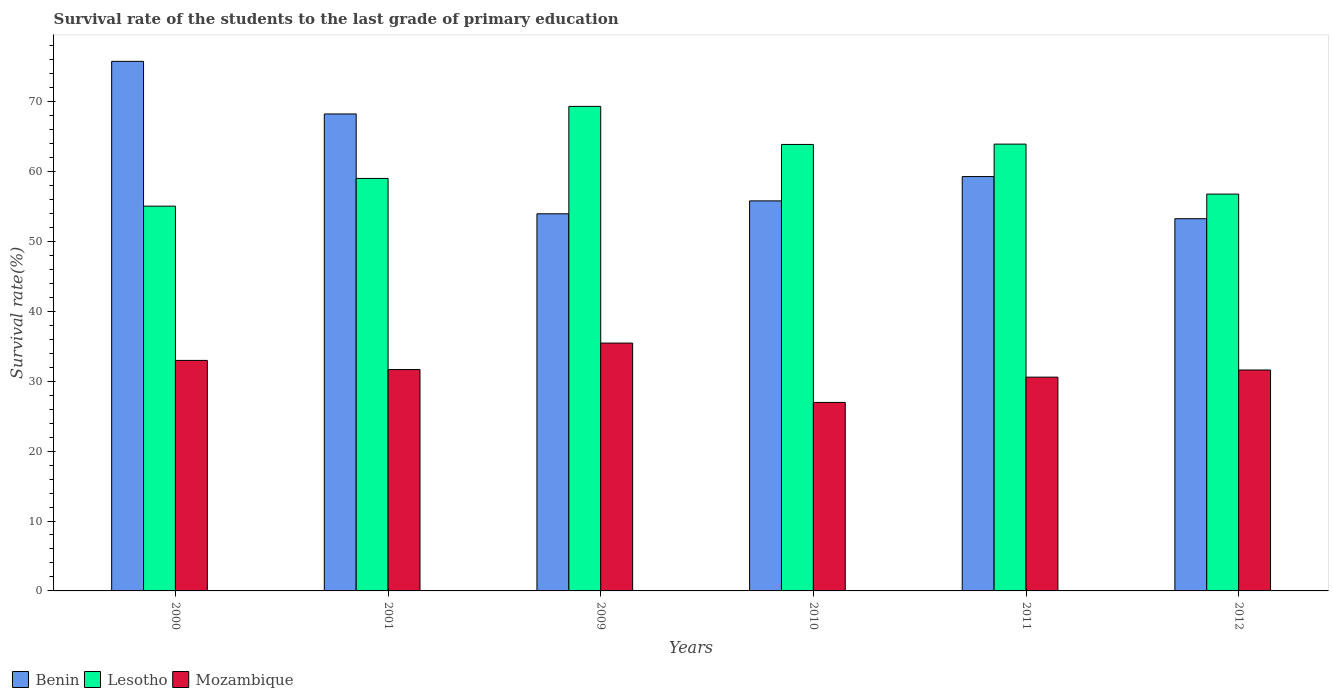How many different coloured bars are there?
Your answer should be very brief. 3. Are the number of bars per tick equal to the number of legend labels?
Your response must be concise. Yes. Are the number of bars on each tick of the X-axis equal?
Provide a succinct answer. Yes. What is the label of the 5th group of bars from the left?
Provide a succinct answer. 2011. In how many cases, is the number of bars for a given year not equal to the number of legend labels?
Provide a short and direct response. 0. What is the survival rate of the students in Benin in 2000?
Provide a short and direct response. 75.74. Across all years, what is the maximum survival rate of the students in Lesotho?
Provide a succinct answer. 69.3. Across all years, what is the minimum survival rate of the students in Benin?
Your answer should be very brief. 53.23. In which year was the survival rate of the students in Benin minimum?
Give a very brief answer. 2012. What is the total survival rate of the students in Lesotho in the graph?
Make the answer very short. 367.83. What is the difference between the survival rate of the students in Lesotho in 2009 and that in 2012?
Your answer should be compact. 12.54. What is the difference between the survival rate of the students in Lesotho in 2011 and the survival rate of the students in Benin in 2001?
Provide a short and direct response. -4.31. What is the average survival rate of the students in Lesotho per year?
Your answer should be compact. 61.31. In the year 2011, what is the difference between the survival rate of the students in Mozambique and survival rate of the students in Lesotho?
Your answer should be compact. -33.33. What is the ratio of the survival rate of the students in Benin in 2009 to that in 2010?
Offer a very short reply. 0.97. Is the survival rate of the students in Benin in 2000 less than that in 2009?
Make the answer very short. No. Is the difference between the survival rate of the students in Mozambique in 2009 and 2012 greater than the difference between the survival rate of the students in Lesotho in 2009 and 2012?
Provide a succinct answer. No. What is the difference between the highest and the second highest survival rate of the students in Lesotho?
Give a very brief answer. 5.4. What is the difference between the highest and the lowest survival rate of the students in Lesotho?
Ensure brevity in your answer.  14.27. Is the sum of the survival rate of the students in Benin in 2011 and 2012 greater than the maximum survival rate of the students in Lesotho across all years?
Provide a short and direct response. Yes. What does the 3rd bar from the left in 2009 represents?
Your response must be concise. Mozambique. What does the 3rd bar from the right in 2012 represents?
Your answer should be very brief. Benin. Is it the case that in every year, the sum of the survival rate of the students in Lesotho and survival rate of the students in Mozambique is greater than the survival rate of the students in Benin?
Ensure brevity in your answer.  Yes. How many bars are there?
Your answer should be very brief. 18. How many years are there in the graph?
Your answer should be very brief. 6. Are the values on the major ticks of Y-axis written in scientific E-notation?
Provide a short and direct response. No. How many legend labels are there?
Provide a succinct answer. 3. How are the legend labels stacked?
Your answer should be compact. Horizontal. What is the title of the graph?
Provide a succinct answer. Survival rate of the students to the last grade of primary education. What is the label or title of the Y-axis?
Make the answer very short. Survival rate(%). What is the Survival rate(%) of Benin in 2000?
Provide a short and direct response. 75.74. What is the Survival rate(%) in Lesotho in 2000?
Provide a short and direct response. 55.03. What is the Survival rate(%) of Mozambique in 2000?
Provide a short and direct response. 32.97. What is the Survival rate(%) in Benin in 2001?
Your answer should be very brief. 68.22. What is the Survival rate(%) in Lesotho in 2001?
Provide a succinct answer. 58.99. What is the Survival rate(%) in Mozambique in 2001?
Provide a short and direct response. 31.66. What is the Survival rate(%) of Benin in 2009?
Make the answer very short. 53.94. What is the Survival rate(%) in Lesotho in 2009?
Your answer should be very brief. 69.3. What is the Survival rate(%) in Mozambique in 2009?
Offer a very short reply. 35.45. What is the Survival rate(%) in Benin in 2010?
Offer a very short reply. 55.78. What is the Survival rate(%) of Lesotho in 2010?
Make the answer very short. 63.85. What is the Survival rate(%) of Mozambique in 2010?
Keep it short and to the point. 26.96. What is the Survival rate(%) of Benin in 2011?
Ensure brevity in your answer.  59.26. What is the Survival rate(%) in Lesotho in 2011?
Make the answer very short. 63.9. What is the Survival rate(%) of Mozambique in 2011?
Your answer should be very brief. 30.57. What is the Survival rate(%) of Benin in 2012?
Keep it short and to the point. 53.23. What is the Survival rate(%) in Lesotho in 2012?
Your response must be concise. 56.75. What is the Survival rate(%) of Mozambique in 2012?
Your answer should be compact. 31.59. Across all years, what is the maximum Survival rate(%) in Benin?
Provide a short and direct response. 75.74. Across all years, what is the maximum Survival rate(%) of Lesotho?
Give a very brief answer. 69.3. Across all years, what is the maximum Survival rate(%) of Mozambique?
Offer a very short reply. 35.45. Across all years, what is the minimum Survival rate(%) in Benin?
Provide a succinct answer. 53.23. Across all years, what is the minimum Survival rate(%) of Lesotho?
Your answer should be compact. 55.03. Across all years, what is the minimum Survival rate(%) in Mozambique?
Ensure brevity in your answer.  26.96. What is the total Survival rate(%) in Benin in the graph?
Offer a very short reply. 366.17. What is the total Survival rate(%) in Lesotho in the graph?
Provide a succinct answer. 367.83. What is the total Survival rate(%) in Mozambique in the graph?
Offer a very short reply. 189.2. What is the difference between the Survival rate(%) in Benin in 2000 and that in 2001?
Ensure brevity in your answer.  7.52. What is the difference between the Survival rate(%) of Lesotho in 2000 and that in 2001?
Keep it short and to the point. -3.96. What is the difference between the Survival rate(%) of Mozambique in 2000 and that in 2001?
Make the answer very short. 1.31. What is the difference between the Survival rate(%) in Benin in 2000 and that in 2009?
Your answer should be compact. 21.8. What is the difference between the Survival rate(%) of Lesotho in 2000 and that in 2009?
Keep it short and to the point. -14.27. What is the difference between the Survival rate(%) of Mozambique in 2000 and that in 2009?
Ensure brevity in your answer.  -2.48. What is the difference between the Survival rate(%) of Benin in 2000 and that in 2010?
Make the answer very short. 19.95. What is the difference between the Survival rate(%) of Lesotho in 2000 and that in 2010?
Keep it short and to the point. -8.82. What is the difference between the Survival rate(%) of Mozambique in 2000 and that in 2010?
Your answer should be very brief. 6.01. What is the difference between the Survival rate(%) in Benin in 2000 and that in 2011?
Provide a succinct answer. 16.48. What is the difference between the Survival rate(%) in Lesotho in 2000 and that in 2011?
Provide a short and direct response. -8.87. What is the difference between the Survival rate(%) in Mozambique in 2000 and that in 2011?
Your answer should be compact. 2.39. What is the difference between the Survival rate(%) of Benin in 2000 and that in 2012?
Provide a succinct answer. 22.5. What is the difference between the Survival rate(%) of Lesotho in 2000 and that in 2012?
Your answer should be very brief. -1.72. What is the difference between the Survival rate(%) of Mozambique in 2000 and that in 2012?
Give a very brief answer. 1.37. What is the difference between the Survival rate(%) in Benin in 2001 and that in 2009?
Your answer should be compact. 14.28. What is the difference between the Survival rate(%) in Lesotho in 2001 and that in 2009?
Provide a succinct answer. -10.3. What is the difference between the Survival rate(%) in Mozambique in 2001 and that in 2009?
Provide a succinct answer. -3.79. What is the difference between the Survival rate(%) of Benin in 2001 and that in 2010?
Offer a very short reply. 12.43. What is the difference between the Survival rate(%) of Lesotho in 2001 and that in 2010?
Your response must be concise. -4.86. What is the difference between the Survival rate(%) of Mozambique in 2001 and that in 2010?
Offer a terse response. 4.7. What is the difference between the Survival rate(%) of Benin in 2001 and that in 2011?
Offer a terse response. 8.95. What is the difference between the Survival rate(%) of Lesotho in 2001 and that in 2011?
Give a very brief answer. -4.91. What is the difference between the Survival rate(%) of Mozambique in 2001 and that in 2011?
Keep it short and to the point. 1.09. What is the difference between the Survival rate(%) in Benin in 2001 and that in 2012?
Keep it short and to the point. 14.98. What is the difference between the Survival rate(%) of Lesotho in 2001 and that in 2012?
Keep it short and to the point. 2.24. What is the difference between the Survival rate(%) of Mozambique in 2001 and that in 2012?
Ensure brevity in your answer.  0.06. What is the difference between the Survival rate(%) in Benin in 2009 and that in 2010?
Offer a terse response. -1.85. What is the difference between the Survival rate(%) in Lesotho in 2009 and that in 2010?
Your answer should be compact. 5.44. What is the difference between the Survival rate(%) in Mozambique in 2009 and that in 2010?
Offer a terse response. 8.48. What is the difference between the Survival rate(%) in Benin in 2009 and that in 2011?
Your response must be concise. -5.32. What is the difference between the Survival rate(%) of Lesotho in 2009 and that in 2011?
Provide a succinct answer. 5.4. What is the difference between the Survival rate(%) in Mozambique in 2009 and that in 2011?
Provide a short and direct response. 4.87. What is the difference between the Survival rate(%) of Benin in 2009 and that in 2012?
Provide a short and direct response. 0.7. What is the difference between the Survival rate(%) of Lesotho in 2009 and that in 2012?
Make the answer very short. 12.54. What is the difference between the Survival rate(%) in Mozambique in 2009 and that in 2012?
Make the answer very short. 3.85. What is the difference between the Survival rate(%) in Benin in 2010 and that in 2011?
Offer a very short reply. -3.48. What is the difference between the Survival rate(%) in Lesotho in 2010 and that in 2011?
Keep it short and to the point. -0.05. What is the difference between the Survival rate(%) in Mozambique in 2010 and that in 2011?
Give a very brief answer. -3.61. What is the difference between the Survival rate(%) of Benin in 2010 and that in 2012?
Provide a short and direct response. 2.55. What is the difference between the Survival rate(%) in Lesotho in 2010 and that in 2012?
Provide a short and direct response. 7.1. What is the difference between the Survival rate(%) in Mozambique in 2010 and that in 2012?
Offer a very short reply. -4.63. What is the difference between the Survival rate(%) in Benin in 2011 and that in 2012?
Give a very brief answer. 6.03. What is the difference between the Survival rate(%) in Lesotho in 2011 and that in 2012?
Keep it short and to the point. 7.15. What is the difference between the Survival rate(%) in Mozambique in 2011 and that in 2012?
Your answer should be very brief. -1.02. What is the difference between the Survival rate(%) in Benin in 2000 and the Survival rate(%) in Lesotho in 2001?
Provide a succinct answer. 16.74. What is the difference between the Survival rate(%) in Benin in 2000 and the Survival rate(%) in Mozambique in 2001?
Provide a short and direct response. 44.08. What is the difference between the Survival rate(%) of Lesotho in 2000 and the Survival rate(%) of Mozambique in 2001?
Offer a very short reply. 23.37. What is the difference between the Survival rate(%) in Benin in 2000 and the Survival rate(%) in Lesotho in 2009?
Your answer should be very brief. 6.44. What is the difference between the Survival rate(%) of Benin in 2000 and the Survival rate(%) of Mozambique in 2009?
Your answer should be very brief. 40.29. What is the difference between the Survival rate(%) of Lesotho in 2000 and the Survival rate(%) of Mozambique in 2009?
Make the answer very short. 19.58. What is the difference between the Survival rate(%) in Benin in 2000 and the Survival rate(%) in Lesotho in 2010?
Ensure brevity in your answer.  11.88. What is the difference between the Survival rate(%) in Benin in 2000 and the Survival rate(%) in Mozambique in 2010?
Make the answer very short. 48.78. What is the difference between the Survival rate(%) in Lesotho in 2000 and the Survival rate(%) in Mozambique in 2010?
Ensure brevity in your answer.  28.07. What is the difference between the Survival rate(%) in Benin in 2000 and the Survival rate(%) in Lesotho in 2011?
Give a very brief answer. 11.84. What is the difference between the Survival rate(%) in Benin in 2000 and the Survival rate(%) in Mozambique in 2011?
Your response must be concise. 45.17. What is the difference between the Survival rate(%) of Lesotho in 2000 and the Survival rate(%) of Mozambique in 2011?
Keep it short and to the point. 24.46. What is the difference between the Survival rate(%) of Benin in 2000 and the Survival rate(%) of Lesotho in 2012?
Give a very brief answer. 18.98. What is the difference between the Survival rate(%) of Benin in 2000 and the Survival rate(%) of Mozambique in 2012?
Your answer should be very brief. 44.14. What is the difference between the Survival rate(%) of Lesotho in 2000 and the Survival rate(%) of Mozambique in 2012?
Make the answer very short. 23.43. What is the difference between the Survival rate(%) in Benin in 2001 and the Survival rate(%) in Lesotho in 2009?
Keep it short and to the point. -1.08. What is the difference between the Survival rate(%) of Benin in 2001 and the Survival rate(%) of Mozambique in 2009?
Ensure brevity in your answer.  32.77. What is the difference between the Survival rate(%) in Lesotho in 2001 and the Survival rate(%) in Mozambique in 2009?
Provide a succinct answer. 23.55. What is the difference between the Survival rate(%) in Benin in 2001 and the Survival rate(%) in Lesotho in 2010?
Your answer should be compact. 4.36. What is the difference between the Survival rate(%) in Benin in 2001 and the Survival rate(%) in Mozambique in 2010?
Your response must be concise. 41.25. What is the difference between the Survival rate(%) in Lesotho in 2001 and the Survival rate(%) in Mozambique in 2010?
Offer a terse response. 32.03. What is the difference between the Survival rate(%) in Benin in 2001 and the Survival rate(%) in Lesotho in 2011?
Ensure brevity in your answer.  4.31. What is the difference between the Survival rate(%) in Benin in 2001 and the Survival rate(%) in Mozambique in 2011?
Your answer should be compact. 37.64. What is the difference between the Survival rate(%) of Lesotho in 2001 and the Survival rate(%) of Mozambique in 2011?
Keep it short and to the point. 28.42. What is the difference between the Survival rate(%) of Benin in 2001 and the Survival rate(%) of Lesotho in 2012?
Provide a succinct answer. 11.46. What is the difference between the Survival rate(%) in Benin in 2001 and the Survival rate(%) in Mozambique in 2012?
Your answer should be very brief. 36.62. What is the difference between the Survival rate(%) in Lesotho in 2001 and the Survival rate(%) in Mozambique in 2012?
Keep it short and to the point. 27.4. What is the difference between the Survival rate(%) in Benin in 2009 and the Survival rate(%) in Lesotho in 2010?
Make the answer very short. -9.92. What is the difference between the Survival rate(%) in Benin in 2009 and the Survival rate(%) in Mozambique in 2010?
Offer a very short reply. 26.98. What is the difference between the Survival rate(%) of Lesotho in 2009 and the Survival rate(%) of Mozambique in 2010?
Provide a succinct answer. 42.34. What is the difference between the Survival rate(%) in Benin in 2009 and the Survival rate(%) in Lesotho in 2011?
Offer a very short reply. -9.97. What is the difference between the Survival rate(%) in Benin in 2009 and the Survival rate(%) in Mozambique in 2011?
Offer a terse response. 23.36. What is the difference between the Survival rate(%) of Lesotho in 2009 and the Survival rate(%) of Mozambique in 2011?
Your answer should be very brief. 38.72. What is the difference between the Survival rate(%) of Benin in 2009 and the Survival rate(%) of Lesotho in 2012?
Make the answer very short. -2.82. What is the difference between the Survival rate(%) in Benin in 2009 and the Survival rate(%) in Mozambique in 2012?
Provide a short and direct response. 22.34. What is the difference between the Survival rate(%) of Lesotho in 2009 and the Survival rate(%) of Mozambique in 2012?
Make the answer very short. 37.7. What is the difference between the Survival rate(%) of Benin in 2010 and the Survival rate(%) of Lesotho in 2011?
Make the answer very short. -8.12. What is the difference between the Survival rate(%) in Benin in 2010 and the Survival rate(%) in Mozambique in 2011?
Give a very brief answer. 25.21. What is the difference between the Survival rate(%) of Lesotho in 2010 and the Survival rate(%) of Mozambique in 2011?
Provide a succinct answer. 33.28. What is the difference between the Survival rate(%) of Benin in 2010 and the Survival rate(%) of Lesotho in 2012?
Your answer should be compact. -0.97. What is the difference between the Survival rate(%) of Benin in 2010 and the Survival rate(%) of Mozambique in 2012?
Provide a short and direct response. 24.19. What is the difference between the Survival rate(%) of Lesotho in 2010 and the Survival rate(%) of Mozambique in 2012?
Offer a terse response. 32.26. What is the difference between the Survival rate(%) of Benin in 2011 and the Survival rate(%) of Lesotho in 2012?
Offer a terse response. 2.51. What is the difference between the Survival rate(%) in Benin in 2011 and the Survival rate(%) in Mozambique in 2012?
Give a very brief answer. 27.67. What is the difference between the Survival rate(%) of Lesotho in 2011 and the Survival rate(%) of Mozambique in 2012?
Provide a succinct answer. 32.31. What is the average Survival rate(%) of Benin per year?
Your answer should be very brief. 61.03. What is the average Survival rate(%) in Lesotho per year?
Keep it short and to the point. 61.31. What is the average Survival rate(%) of Mozambique per year?
Ensure brevity in your answer.  31.53. In the year 2000, what is the difference between the Survival rate(%) in Benin and Survival rate(%) in Lesotho?
Your answer should be very brief. 20.71. In the year 2000, what is the difference between the Survival rate(%) in Benin and Survival rate(%) in Mozambique?
Provide a succinct answer. 42.77. In the year 2000, what is the difference between the Survival rate(%) of Lesotho and Survival rate(%) of Mozambique?
Offer a very short reply. 22.06. In the year 2001, what is the difference between the Survival rate(%) in Benin and Survival rate(%) in Lesotho?
Your answer should be compact. 9.22. In the year 2001, what is the difference between the Survival rate(%) in Benin and Survival rate(%) in Mozambique?
Offer a terse response. 36.56. In the year 2001, what is the difference between the Survival rate(%) of Lesotho and Survival rate(%) of Mozambique?
Offer a terse response. 27.33. In the year 2009, what is the difference between the Survival rate(%) in Benin and Survival rate(%) in Lesotho?
Make the answer very short. -15.36. In the year 2009, what is the difference between the Survival rate(%) of Benin and Survival rate(%) of Mozambique?
Make the answer very short. 18.49. In the year 2009, what is the difference between the Survival rate(%) in Lesotho and Survival rate(%) in Mozambique?
Your answer should be very brief. 33.85. In the year 2010, what is the difference between the Survival rate(%) of Benin and Survival rate(%) of Lesotho?
Make the answer very short. -8.07. In the year 2010, what is the difference between the Survival rate(%) in Benin and Survival rate(%) in Mozambique?
Provide a succinct answer. 28.82. In the year 2010, what is the difference between the Survival rate(%) in Lesotho and Survival rate(%) in Mozambique?
Your answer should be very brief. 36.89. In the year 2011, what is the difference between the Survival rate(%) in Benin and Survival rate(%) in Lesotho?
Offer a very short reply. -4.64. In the year 2011, what is the difference between the Survival rate(%) in Benin and Survival rate(%) in Mozambique?
Your answer should be very brief. 28.69. In the year 2011, what is the difference between the Survival rate(%) in Lesotho and Survival rate(%) in Mozambique?
Your answer should be very brief. 33.33. In the year 2012, what is the difference between the Survival rate(%) in Benin and Survival rate(%) in Lesotho?
Offer a terse response. -3.52. In the year 2012, what is the difference between the Survival rate(%) of Benin and Survival rate(%) of Mozambique?
Your answer should be very brief. 21.64. In the year 2012, what is the difference between the Survival rate(%) in Lesotho and Survival rate(%) in Mozambique?
Your response must be concise. 25.16. What is the ratio of the Survival rate(%) in Benin in 2000 to that in 2001?
Make the answer very short. 1.11. What is the ratio of the Survival rate(%) in Lesotho in 2000 to that in 2001?
Your answer should be compact. 0.93. What is the ratio of the Survival rate(%) in Mozambique in 2000 to that in 2001?
Keep it short and to the point. 1.04. What is the ratio of the Survival rate(%) in Benin in 2000 to that in 2009?
Provide a short and direct response. 1.4. What is the ratio of the Survival rate(%) of Lesotho in 2000 to that in 2009?
Your answer should be very brief. 0.79. What is the ratio of the Survival rate(%) in Mozambique in 2000 to that in 2009?
Your answer should be very brief. 0.93. What is the ratio of the Survival rate(%) of Benin in 2000 to that in 2010?
Your answer should be compact. 1.36. What is the ratio of the Survival rate(%) of Lesotho in 2000 to that in 2010?
Keep it short and to the point. 0.86. What is the ratio of the Survival rate(%) in Mozambique in 2000 to that in 2010?
Provide a succinct answer. 1.22. What is the ratio of the Survival rate(%) in Benin in 2000 to that in 2011?
Make the answer very short. 1.28. What is the ratio of the Survival rate(%) of Lesotho in 2000 to that in 2011?
Ensure brevity in your answer.  0.86. What is the ratio of the Survival rate(%) in Mozambique in 2000 to that in 2011?
Keep it short and to the point. 1.08. What is the ratio of the Survival rate(%) in Benin in 2000 to that in 2012?
Your answer should be compact. 1.42. What is the ratio of the Survival rate(%) in Lesotho in 2000 to that in 2012?
Your response must be concise. 0.97. What is the ratio of the Survival rate(%) in Mozambique in 2000 to that in 2012?
Provide a succinct answer. 1.04. What is the ratio of the Survival rate(%) of Benin in 2001 to that in 2009?
Provide a succinct answer. 1.26. What is the ratio of the Survival rate(%) in Lesotho in 2001 to that in 2009?
Your response must be concise. 0.85. What is the ratio of the Survival rate(%) of Mozambique in 2001 to that in 2009?
Give a very brief answer. 0.89. What is the ratio of the Survival rate(%) in Benin in 2001 to that in 2010?
Ensure brevity in your answer.  1.22. What is the ratio of the Survival rate(%) of Lesotho in 2001 to that in 2010?
Provide a short and direct response. 0.92. What is the ratio of the Survival rate(%) of Mozambique in 2001 to that in 2010?
Provide a succinct answer. 1.17. What is the ratio of the Survival rate(%) of Benin in 2001 to that in 2011?
Provide a succinct answer. 1.15. What is the ratio of the Survival rate(%) in Lesotho in 2001 to that in 2011?
Your answer should be very brief. 0.92. What is the ratio of the Survival rate(%) in Mozambique in 2001 to that in 2011?
Your answer should be compact. 1.04. What is the ratio of the Survival rate(%) in Benin in 2001 to that in 2012?
Give a very brief answer. 1.28. What is the ratio of the Survival rate(%) of Lesotho in 2001 to that in 2012?
Give a very brief answer. 1.04. What is the ratio of the Survival rate(%) in Mozambique in 2001 to that in 2012?
Make the answer very short. 1. What is the ratio of the Survival rate(%) in Benin in 2009 to that in 2010?
Give a very brief answer. 0.97. What is the ratio of the Survival rate(%) of Lesotho in 2009 to that in 2010?
Keep it short and to the point. 1.09. What is the ratio of the Survival rate(%) in Mozambique in 2009 to that in 2010?
Give a very brief answer. 1.31. What is the ratio of the Survival rate(%) in Benin in 2009 to that in 2011?
Offer a very short reply. 0.91. What is the ratio of the Survival rate(%) in Lesotho in 2009 to that in 2011?
Offer a very short reply. 1.08. What is the ratio of the Survival rate(%) of Mozambique in 2009 to that in 2011?
Your response must be concise. 1.16. What is the ratio of the Survival rate(%) in Benin in 2009 to that in 2012?
Your response must be concise. 1.01. What is the ratio of the Survival rate(%) in Lesotho in 2009 to that in 2012?
Your answer should be very brief. 1.22. What is the ratio of the Survival rate(%) in Mozambique in 2009 to that in 2012?
Your response must be concise. 1.12. What is the ratio of the Survival rate(%) of Benin in 2010 to that in 2011?
Keep it short and to the point. 0.94. What is the ratio of the Survival rate(%) in Lesotho in 2010 to that in 2011?
Provide a succinct answer. 1. What is the ratio of the Survival rate(%) of Mozambique in 2010 to that in 2011?
Provide a succinct answer. 0.88. What is the ratio of the Survival rate(%) of Benin in 2010 to that in 2012?
Ensure brevity in your answer.  1.05. What is the ratio of the Survival rate(%) in Lesotho in 2010 to that in 2012?
Provide a succinct answer. 1.13. What is the ratio of the Survival rate(%) in Mozambique in 2010 to that in 2012?
Provide a succinct answer. 0.85. What is the ratio of the Survival rate(%) of Benin in 2011 to that in 2012?
Offer a very short reply. 1.11. What is the ratio of the Survival rate(%) of Lesotho in 2011 to that in 2012?
Provide a short and direct response. 1.13. What is the difference between the highest and the second highest Survival rate(%) of Benin?
Your answer should be compact. 7.52. What is the difference between the highest and the second highest Survival rate(%) in Lesotho?
Make the answer very short. 5.4. What is the difference between the highest and the second highest Survival rate(%) in Mozambique?
Your answer should be compact. 2.48. What is the difference between the highest and the lowest Survival rate(%) in Benin?
Keep it short and to the point. 22.5. What is the difference between the highest and the lowest Survival rate(%) of Lesotho?
Keep it short and to the point. 14.27. What is the difference between the highest and the lowest Survival rate(%) in Mozambique?
Your answer should be compact. 8.48. 